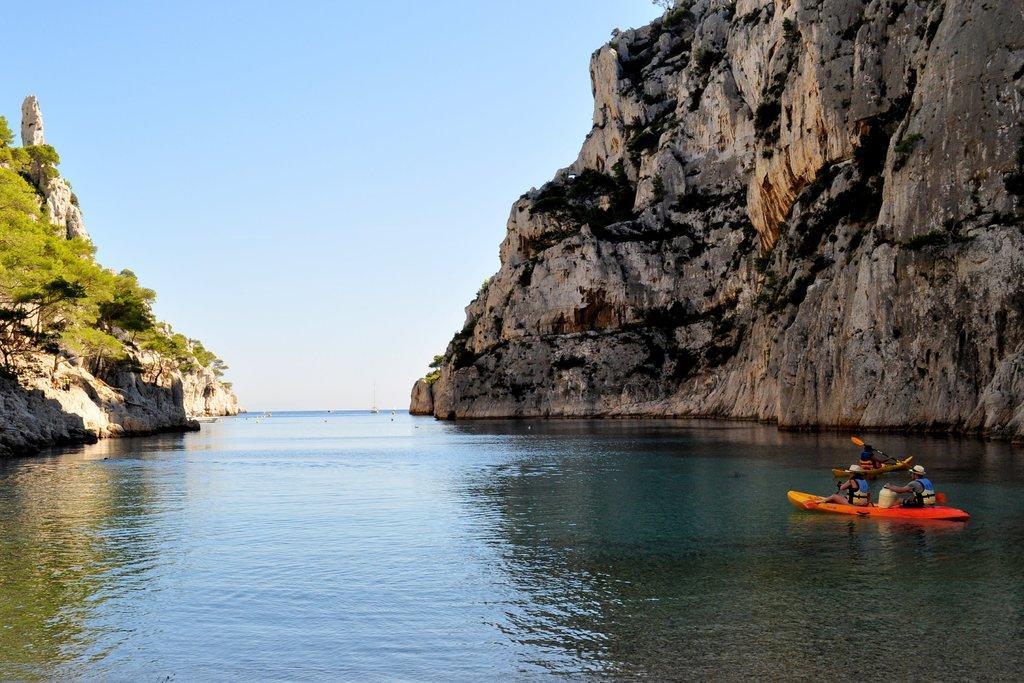Please provide a concise description of this image. There is water. On the right side there is a rock hill and boats in the water. On the boat there are people sitting. On the left side there is a hill with trees. In the background there is sky. 